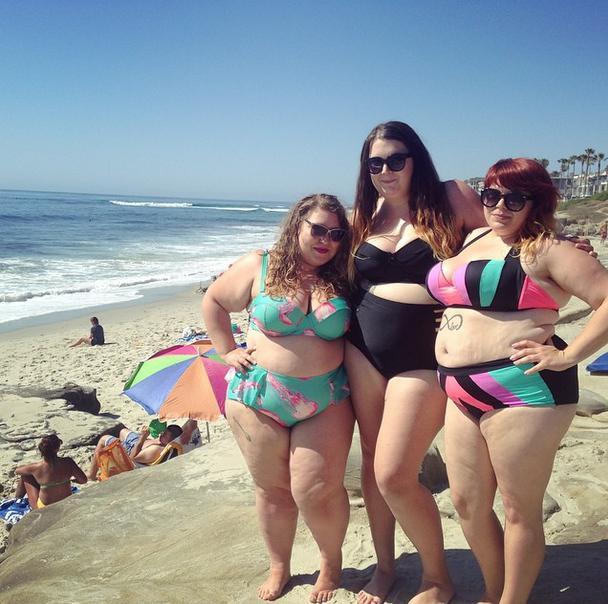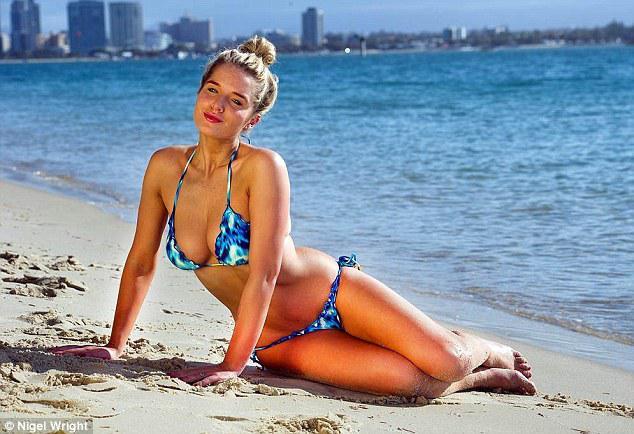The first image is the image on the left, the second image is the image on the right. For the images shown, is this caption "Three women are in swimsuits near the water." true? Answer yes or no. No. The first image is the image on the left, the second image is the image on the right. Examine the images to the left and right. Is the description "An image shows three bikini models facing the ocean, with backs to the camera." accurate? Answer yes or no. No. 